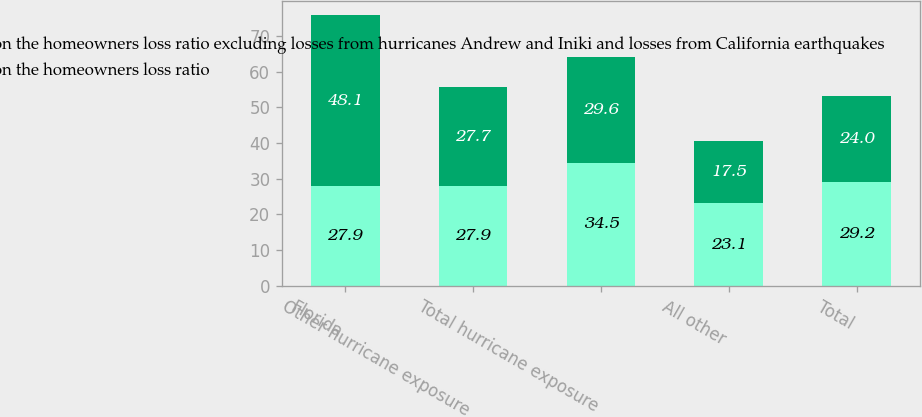Convert chart. <chart><loc_0><loc_0><loc_500><loc_500><stacked_bar_chart><ecel><fcel>Florida<fcel>Other hurricane exposure<fcel>Total hurricane exposure<fcel>All other<fcel>Total<nl><fcel>Average annual impact of catastrophes on the homeowners loss ratio excluding losses from hurricanes Andrew and Iniki and losses from California earthquakes<fcel>27.9<fcel>27.9<fcel>34.5<fcel>23.1<fcel>29.2<nl><fcel>Average annual impact of catastrophes on the homeowners loss ratio<fcel>48.1<fcel>27.7<fcel>29.6<fcel>17.5<fcel>24<nl></chart> 